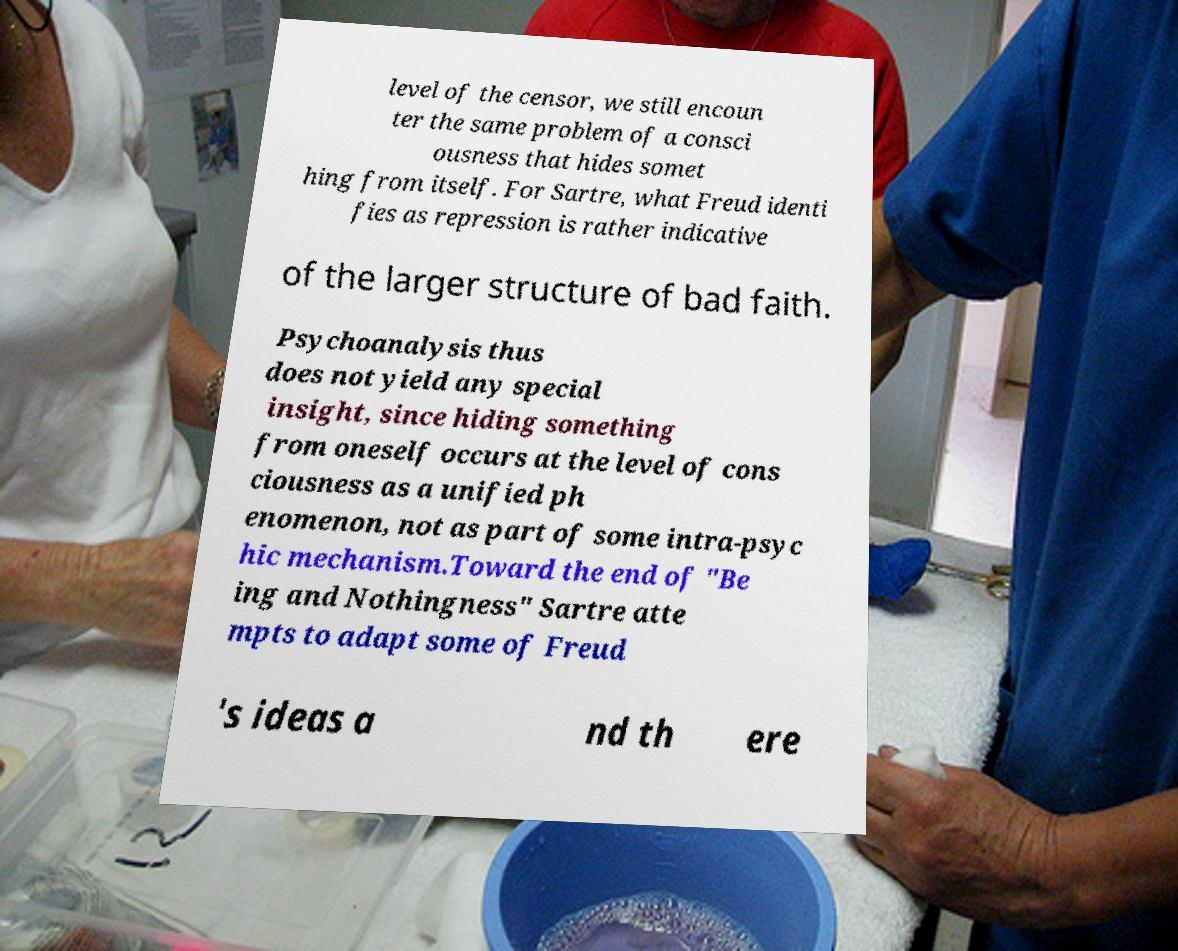Could you extract and type out the text from this image? level of the censor, we still encoun ter the same problem of a consci ousness that hides somet hing from itself. For Sartre, what Freud identi fies as repression is rather indicative of the larger structure of bad faith. Psychoanalysis thus does not yield any special insight, since hiding something from oneself occurs at the level of cons ciousness as a unified ph enomenon, not as part of some intra-psyc hic mechanism.Toward the end of "Be ing and Nothingness" Sartre atte mpts to adapt some of Freud 's ideas a nd th ere 